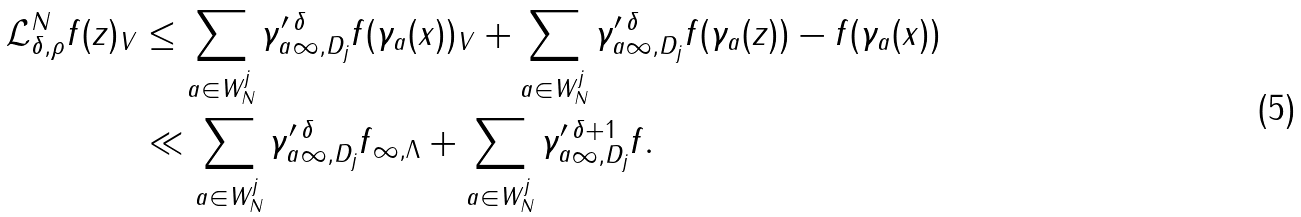<formula> <loc_0><loc_0><loc_500><loc_500>\| \mathcal { L } _ { \delta , \rho } ^ { N } f ( z ) \| _ { V } & \leq \sum _ { a \in W _ { N } ^ { j } } \| \gamma _ { a } ^ { \prime } \| _ { \infty , D _ { j } } ^ { \delta } \| f ( \gamma _ { a } ( x ) ) \| _ { V } + \sum _ { a \in W _ { N } ^ { j } } \| \gamma _ { a } ^ { \prime } \| _ { \infty , D _ { j } } ^ { \delta } \| f ( \gamma _ { a } ( z ) ) - f ( \gamma _ { a } ( x ) ) \| \\ & \ll \sum _ { a \in W _ { N } ^ { j } } \| \gamma _ { a } ^ { \prime } \| _ { \infty , D _ { j } } ^ { \delta } \| f \| _ { \infty , \Lambda } + \sum _ { a \in W _ { N } ^ { j } } \| \gamma _ { a } ^ { \prime } \| _ { \infty , D _ { j } } ^ { \delta + 1 } \| f \| .</formula> 